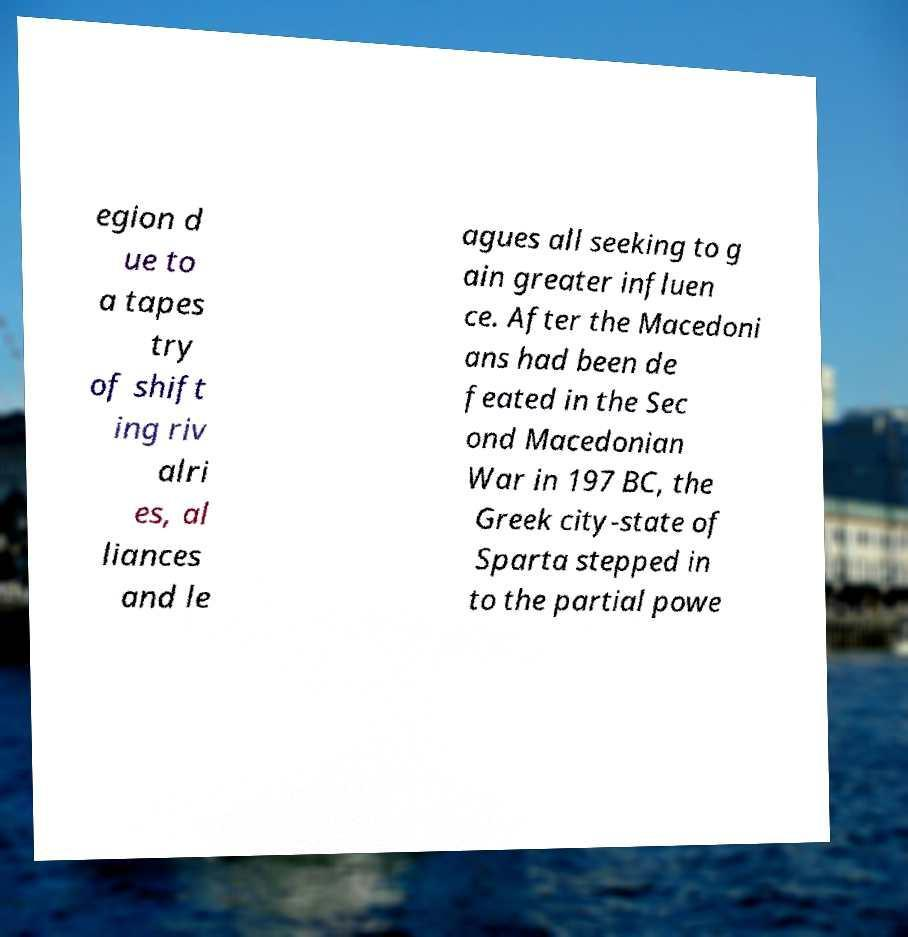There's text embedded in this image that I need extracted. Can you transcribe it verbatim? egion d ue to a tapes try of shift ing riv alri es, al liances and le agues all seeking to g ain greater influen ce. After the Macedoni ans had been de feated in the Sec ond Macedonian War in 197 BC, the Greek city-state of Sparta stepped in to the partial powe 